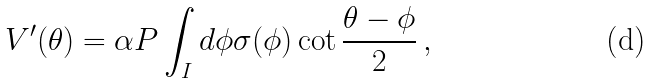Convert formula to latex. <formula><loc_0><loc_0><loc_500><loc_500>V ^ { \prime } ( \theta ) = \alpha P \int _ { I } d \phi \sigma ( \phi ) \cot \frac { \theta - \phi } { 2 } \, ,</formula> 